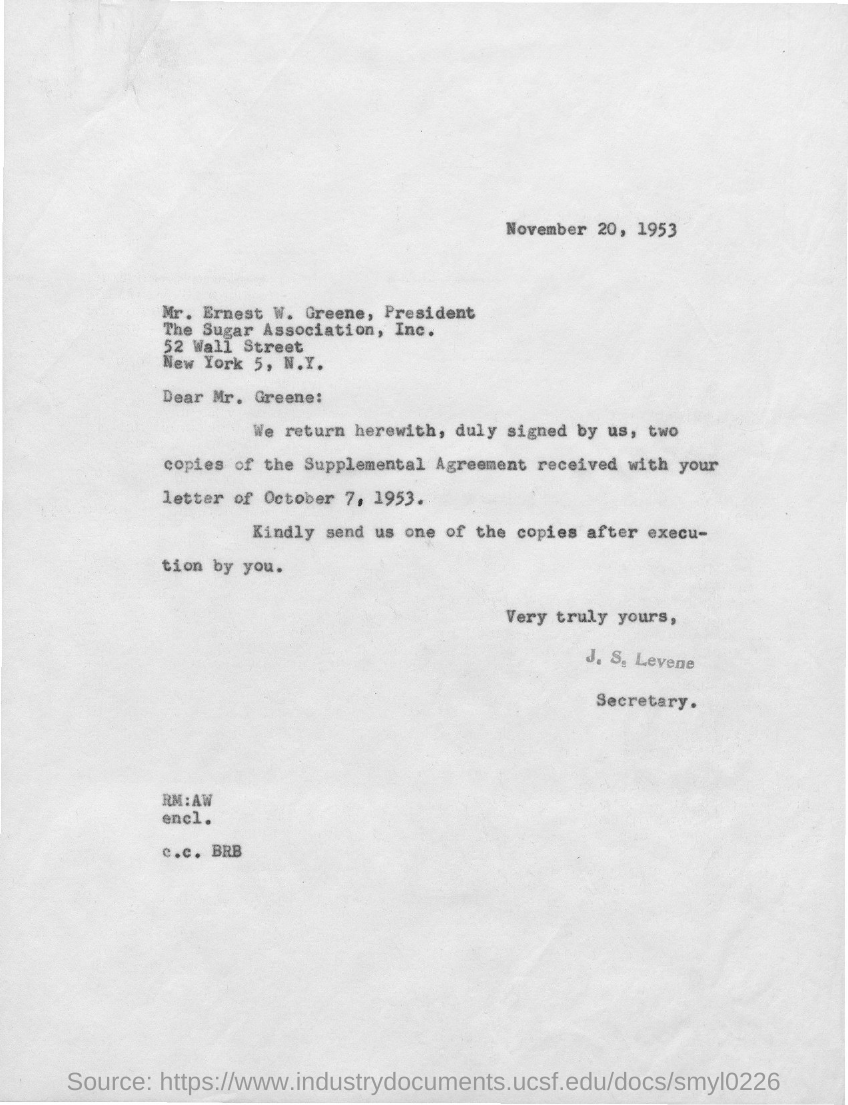What is the issued date of this letter?
Ensure brevity in your answer.  November 20, 1953. Who is the sender of this letter?
Offer a terse response. J. S. Levene. What is the designation of J. S. Levene?
Offer a terse response. Secretary. Who is the addressee of this letter?
Give a very brief answer. Mr. Greene. 